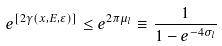<formula> <loc_0><loc_0><loc_500><loc_500>e ^ { [ 2 \gamma ( x , E , \varepsilon ) ] } \leq e ^ { 2 \pi \mu _ { l } } \equiv \frac { 1 } { 1 - e ^ { - 4 \sigma _ { l } } }</formula> 